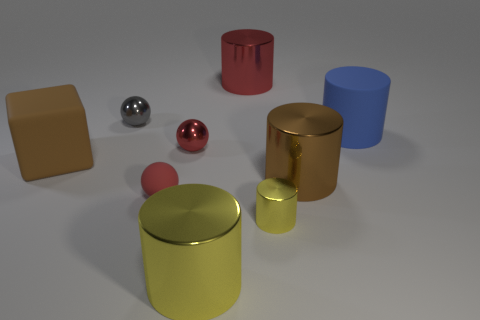There is a large cylinder that is the same color as the big cube; what is its material?
Keep it short and to the point. Metal. The red thing that is the same shape as the blue object is what size?
Your response must be concise. Large. Is the number of big yellow things on the right side of the tiny cylinder greater than the number of tiny yellow metallic things to the left of the large cube?
Your answer should be compact. No. There is a cylinder that is behind the tiny yellow shiny cylinder and in front of the blue matte object; what is its material?
Provide a short and direct response. Metal. There is another shiny thing that is the same shape as the gray object; what is its color?
Your response must be concise. Red. The gray thing has what size?
Your answer should be compact. Small. The big object that is on the left side of the large shiny thing that is left of the red cylinder is what color?
Make the answer very short. Brown. How many big metal things are both on the left side of the small yellow thing and behind the red matte ball?
Make the answer very short. 1. Is the number of blue balls greater than the number of blue rubber cylinders?
Make the answer very short. No. What material is the block?
Ensure brevity in your answer.  Rubber. 